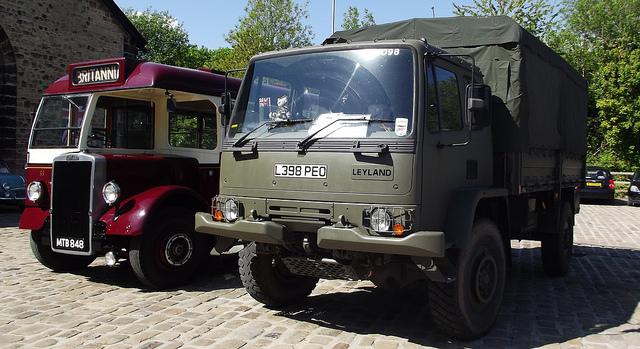Which vehicle is for military use?
Answer briefly. Yes. Are these vehicles for personal/everyday use?
Answer briefly. No. Is this photo probably taken in the United States?
Concise answer only. No. 